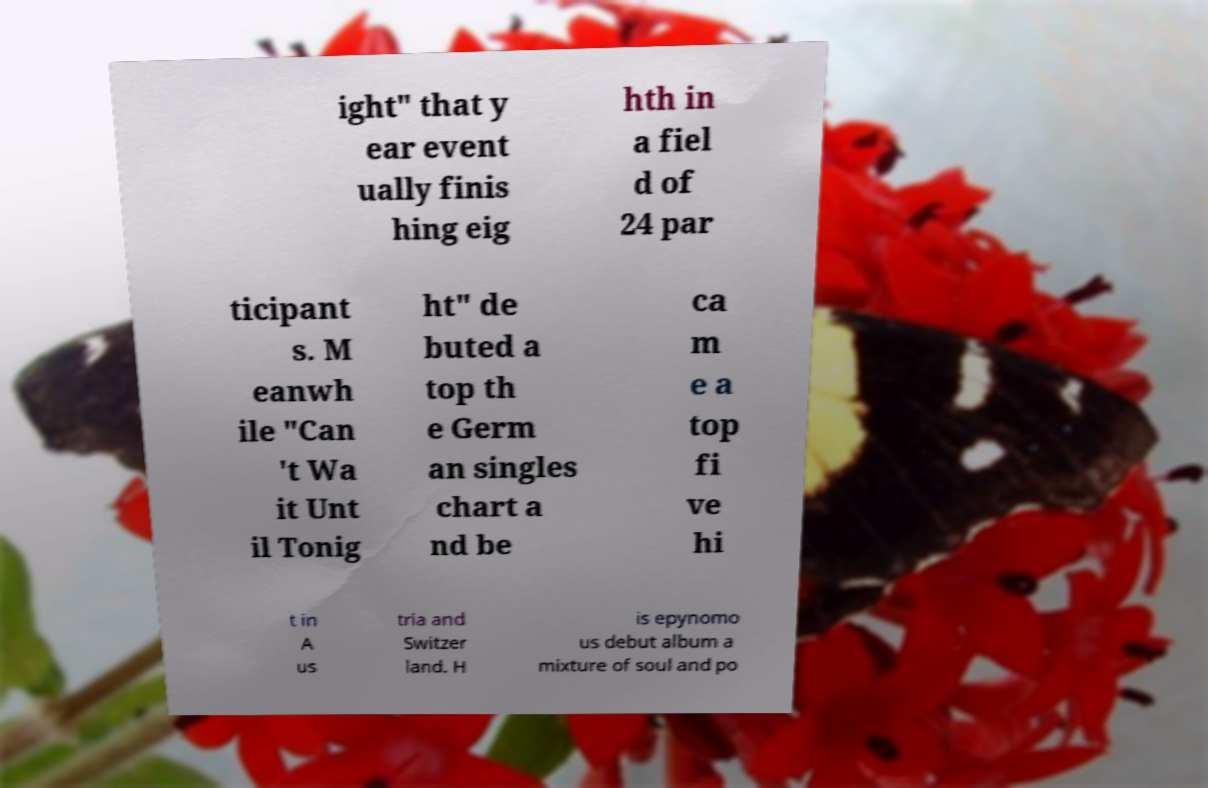What messages or text are displayed in this image? I need them in a readable, typed format. ight" that y ear event ually finis hing eig hth in a fiel d of 24 par ticipant s. M eanwh ile "Can 't Wa it Unt il Tonig ht" de buted a top th e Germ an singles chart a nd be ca m e a top fi ve hi t in A us tria and Switzer land. H is epynomo us debut album a mixture of soul and po 